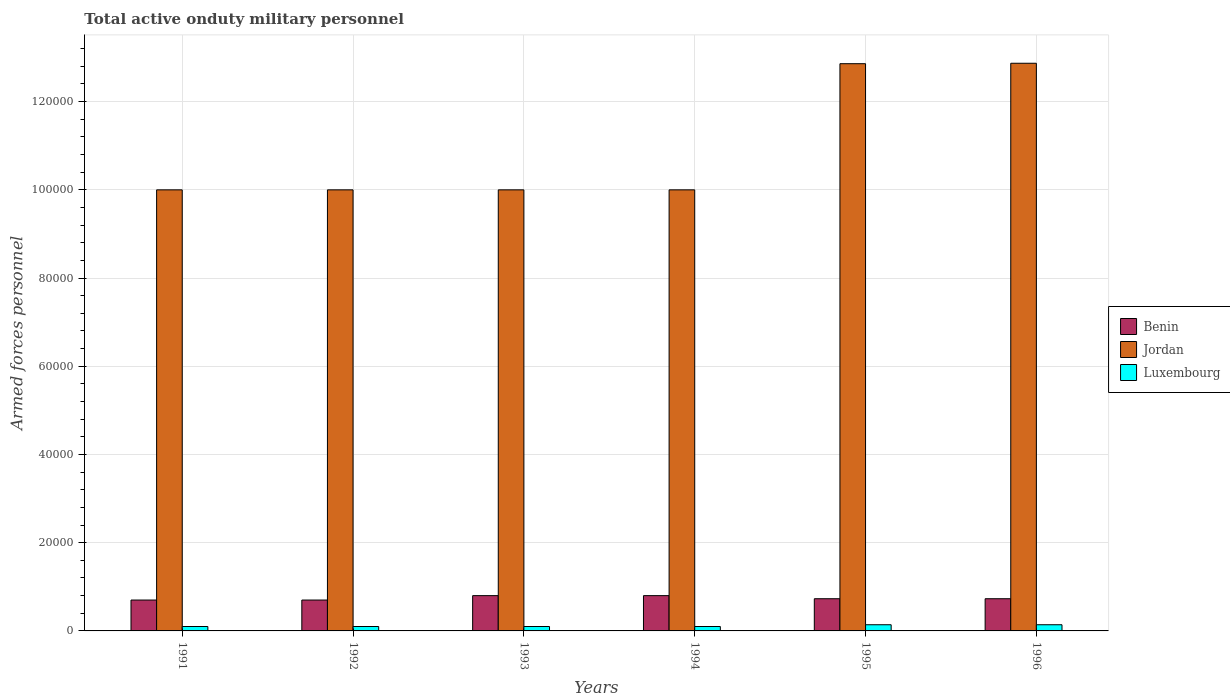How many different coloured bars are there?
Ensure brevity in your answer.  3. Are the number of bars on each tick of the X-axis equal?
Provide a short and direct response. Yes. How many bars are there on the 6th tick from the left?
Your response must be concise. 3. What is the label of the 2nd group of bars from the left?
Provide a succinct answer. 1992. What is the number of armed forces personnel in Jordan in 1995?
Your answer should be compact. 1.29e+05. Across all years, what is the maximum number of armed forces personnel in Luxembourg?
Your response must be concise. 1400. Across all years, what is the minimum number of armed forces personnel in Benin?
Your answer should be very brief. 7000. In which year was the number of armed forces personnel in Benin minimum?
Keep it short and to the point. 1991. What is the total number of armed forces personnel in Benin in the graph?
Make the answer very short. 4.46e+04. What is the difference between the number of armed forces personnel in Jordan in 1991 and that in 1995?
Provide a short and direct response. -2.86e+04. What is the difference between the number of armed forces personnel in Luxembourg in 1992 and the number of armed forces personnel in Jordan in 1995?
Offer a very short reply. -1.28e+05. What is the average number of armed forces personnel in Luxembourg per year?
Ensure brevity in your answer.  1133.33. In the year 1994, what is the difference between the number of armed forces personnel in Jordan and number of armed forces personnel in Luxembourg?
Your answer should be very brief. 9.90e+04. What is the ratio of the number of armed forces personnel in Jordan in 1993 to that in 1994?
Provide a succinct answer. 1. Is the number of armed forces personnel in Luxembourg in 1995 less than that in 1996?
Provide a short and direct response. No. What is the difference between the highest and the second highest number of armed forces personnel in Luxembourg?
Keep it short and to the point. 0. Is the sum of the number of armed forces personnel in Benin in 1992 and 1996 greater than the maximum number of armed forces personnel in Luxembourg across all years?
Provide a succinct answer. Yes. What does the 2nd bar from the left in 1995 represents?
Offer a very short reply. Jordan. What does the 2nd bar from the right in 1993 represents?
Offer a terse response. Jordan. How many bars are there?
Offer a terse response. 18. How many years are there in the graph?
Offer a terse response. 6. Are the values on the major ticks of Y-axis written in scientific E-notation?
Offer a very short reply. No. Where does the legend appear in the graph?
Ensure brevity in your answer.  Center right. How many legend labels are there?
Your answer should be very brief. 3. How are the legend labels stacked?
Make the answer very short. Vertical. What is the title of the graph?
Offer a very short reply. Total active onduty military personnel. What is the label or title of the Y-axis?
Give a very brief answer. Armed forces personnel. What is the Armed forces personnel of Benin in 1991?
Your response must be concise. 7000. What is the Armed forces personnel in Jordan in 1991?
Provide a succinct answer. 1.00e+05. What is the Armed forces personnel of Luxembourg in 1991?
Offer a terse response. 1000. What is the Armed forces personnel of Benin in 1992?
Offer a very short reply. 7000. What is the Armed forces personnel of Jordan in 1992?
Provide a succinct answer. 1.00e+05. What is the Armed forces personnel in Luxembourg in 1992?
Provide a short and direct response. 1000. What is the Armed forces personnel of Benin in 1993?
Keep it short and to the point. 8000. What is the Armed forces personnel of Jordan in 1993?
Ensure brevity in your answer.  1.00e+05. What is the Armed forces personnel in Benin in 1994?
Offer a terse response. 8000. What is the Armed forces personnel of Jordan in 1994?
Make the answer very short. 1.00e+05. What is the Armed forces personnel in Luxembourg in 1994?
Make the answer very short. 1000. What is the Armed forces personnel of Benin in 1995?
Offer a very short reply. 7300. What is the Armed forces personnel of Jordan in 1995?
Your response must be concise. 1.29e+05. What is the Armed forces personnel in Luxembourg in 1995?
Keep it short and to the point. 1400. What is the Armed forces personnel of Benin in 1996?
Make the answer very short. 7300. What is the Armed forces personnel of Jordan in 1996?
Offer a very short reply. 1.29e+05. What is the Armed forces personnel in Luxembourg in 1996?
Offer a terse response. 1400. Across all years, what is the maximum Armed forces personnel of Benin?
Give a very brief answer. 8000. Across all years, what is the maximum Armed forces personnel of Jordan?
Provide a short and direct response. 1.29e+05. Across all years, what is the maximum Armed forces personnel of Luxembourg?
Offer a terse response. 1400. Across all years, what is the minimum Armed forces personnel in Benin?
Give a very brief answer. 7000. Across all years, what is the minimum Armed forces personnel in Jordan?
Make the answer very short. 1.00e+05. Across all years, what is the minimum Armed forces personnel of Luxembourg?
Ensure brevity in your answer.  1000. What is the total Armed forces personnel in Benin in the graph?
Make the answer very short. 4.46e+04. What is the total Armed forces personnel of Jordan in the graph?
Give a very brief answer. 6.57e+05. What is the total Armed forces personnel in Luxembourg in the graph?
Your response must be concise. 6800. What is the difference between the Armed forces personnel in Benin in 1991 and that in 1992?
Your answer should be very brief. 0. What is the difference between the Armed forces personnel of Jordan in 1991 and that in 1992?
Ensure brevity in your answer.  0. What is the difference between the Armed forces personnel of Benin in 1991 and that in 1993?
Your answer should be compact. -1000. What is the difference between the Armed forces personnel in Jordan in 1991 and that in 1993?
Ensure brevity in your answer.  0. What is the difference between the Armed forces personnel of Luxembourg in 1991 and that in 1993?
Your answer should be compact. 0. What is the difference between the Armed forces personnel of Benin in 1991 and that in 1994?
Ensure brevity in your answer.  -1000. What is the difference between the Armed forces personnel of Benin in 1991 and that in 1995?
Keep it short and to the point. -300. What is the difference between the Armed forces personnel in Jordan in 1991 and that in 1995?
Your response must be concise. -2.86e+04. What is the difference between the Armed forces personnel in Luxembourg in 1991 and that in 1995?
Make the answer very short. -400. What is the difference between the Armed forces personnel of Benin in 1991 and that in 1996?
Provide a short and direct response. -300. What is the difference between the Armed forces personnel of Jordan in 1991 and that in 1996?
Give a very brief answer. -2.87e+04. What is the difference between the Armed forces personnel of Luxembourg in 1991 and that in 1996?
Keep it short and to the point. -400. What is the difference between the Armed forces personnel in Benin in 1992 and that in 1993?
Provide a succinct answer. -1000. What is the difference between the Armed forces personnel in Jordan in 1992 and that in 1993?
Provide a short and direct response. 0. What is the difference between the Armed forces personnel of Luxembourg in 1992 and that in 1993?
Offer a very short reply. 0. What is the difference between the Armed forces personnel of Benin in 1992 and that in 1994?
Your answer should be compact. -1000. What is the difference between the Armed forces personnel of Benin in 1992 and that in 1995?
Ensure brevity in your answer.  -300. What is the difference between the Armed forces personnel in Jordan in 1992 and that in 1995?
Ensure brevity in your answer.  -2.86e+04. What is the difference between the Armed forces personnel of Luxembourg in 1992 and that in 1995?
Make the answer very short. -400. What is the difference between the Armed forces personnel of Benin in 1992 and that in 1996?
Your answer should be compact. -300. What is the difference between the Armed forces personnel of Jordan in 1992 and that in 1996?
Your answer should be very brief. -2.87e+04. What is the difference between the Armed forces personnel of Luxembourg in 1992 and that in 1996?
Your answer should be compact. -400. What is the difference between the Armed forces personnel in Benin in 1993 and that in 1994?
Give a very brief answer. 0. What is the difference between the Armed forces personnel in Jordan in 1993 and that in 1994?
Your response must be concise. 0. What is the difference between the Armed forces personnel of Luxembourg in 1993 and that in 1994?
Make the answer very short. 0. What is the difference between the Armed forces personnel of Benin in 1993 and that in 1995?
Your answer should be very brief. 700. What is the difference between the Armed forces personnel in Jordan in 1993 and that in 1995?
Ensure brevity in your answer.  -2.86e+04. What is the difference between the Armed forces personnel in Luxembourg in 1993 and that in 1995?
Ensure brevity in your answer.  -400. What is the difference between the Armed forces personnel in Benin in 1993 and that in 1996?
Provide a succinct answer. 700. What is the difference between the Armed forces personnel of Jordan in 1993 and that in 1996?
Make the answer very short. -2.87e+04. What is the difference between the Armed forces personnel of Luxembourg in 1993 and that in 1996?
Make the answer very short. -400. What is the difference between the Armed forces personnel in Benin in 1994 and that in 1995?
Keep it short and to the point. 700. What is the difference between the Armed forces personnel in Jordan in 1994 and that in 1995?
Provide a succinct answer. -2.86e+04. What is the difference between the Armed forces personnel in Luxembourg in 1994 and that in 1995?
Your answer should be very brief. -400. What is the difference between the Armed forces personnel in Benin in 1994 and that in 1996?
Your answer should be very brief. 700. What is the difference between the Armed forces personnel in Jordan in 1994 and that in 1996?
Provide a short and direct response. -2.87e+04. What is the difference between the Armed forces personnel in Luxembourg in 1994 and that in 1996?
Your answer should be compact. -400. What is the difference between the Armed forces personnel of Jordan in 1995 and that in 1996?
Your answer should be compact. -100. What is the difference between the Armed forces personnel of Luxembourg in 1995 and that in 1996?
Your response must be concise. 0. What is the difference between the Armed forces personnel in Benin in 1991 and the Armed forces personnel in Jordan in 1992?
Your answer should be very brief. -9.30e+04. What is the difference between the Armed forces personnel of Benin in 1991 and the Armed forces personnel of Luxembourg in 1992?
Your response must be concise. 6000. What is the difference between the Armed forces personnel in Jordan in 1991 and the Armed forces personnel in Luxembourg in 1992?
Your answer should be very brief. 9.90e+04. What is the difference between the Armed forces personnel of Benin in 1991 and the Armed forces personnel of Jordan in 1993?
Keep it short and to the point. -9.30e+04. What is the difference between the Armed forces personnel in Benin in 1991 and the Armed forces personnel in Luxembourg in 1993?
Your response must be concise. 6000. What is the difference between the Armed forces personnel in Jordan in 1991 and the Armed forces personnel in Luxembourg in 1993?
Provide a succinct answer. 9.90e+04. What is the difference between the Armed forces personnel of Benin in 1991 and the Armed forces personnel of Jordan in 1994?
Give a very brief answer. -9.30e+04. What is the difference between the Armed forces personnel of Benin in 1991 and the Armed forces personnel of Luxembourg in 1994?
Your answer should be very brief. 6000. What is the difference between the Armed forces personnel of Jordan in 1991 and the Armed forces personnel of Luxembourg in 1994?
Make the answer very short. 9.90e+04. What is the difference between the Armed forces personnel of Benin in 1991 and the Armed forces personnel of Jordan in 1995?
Keep it short and to the point. -1.22e+05. What is the difference between the Armed forces personnel of Benin in 1991 and the Armed forces personnel of Luxembourg in 1995?
Provide a short and direct response. 5600. What is the difference between the Armed forces personnel in Jordan in 1991 and the Armed forces personnel in Luxembourg in 1995?
Provide a short and direct response. 9.86e+04. What is the difference between the Armed forces personnel of Benin in 1991 and the Armed forces personnel of Jordan in 1996?
Provide a short and direct response. -1.22e+05. What is the difference between the Armed forces personnel in Benin in 1991 and the Armed forces personnel in Luxembourg in 1996?
Keep it short and to the point. 5600. What is the difference between the Armed forces personnel of Jordan in 1991 and the Armed forces personnel of Luxembourg in 1996?
Ensure brevity in your answer.  9.86e+04. What is the difference between the Armed forces personnel in Benin in 1992 and the Armed forces personnel in Jordan in 1993?
Keep it short and to the point. -9.30e+04. What is the difference between the Armed forces personnel in Benin in 1992 and the Armed forces personnel in Luxembourg in 1993?
Keep it short and to the point. 6000. What is the difference between the Armed forces personnel of Jordan in 1992 and the Armed forces personnel of Luxembourg in 1993?
Ensure brevity in your answer.  9.90e+04. What is the difference between the Armed forces personnel in Benin in 1992 and the Armed forces personnel in Jordan in 1994?
Ensure brevity in your answer.  -9.30e+04. What is the difference between the Armed forces personnel in Benin in 1992 and the Armed forces personnel in Luxembourg in 1994?
Your answer should be compact. 6000. What is the difference between the Armed forces personnel of Jordan in 1992 and the Armed forces personnel of Luxembourg in 1994?
Your response must be concise. 9.90e+04. What is the difference between the Armed forces personnel in Benin in 1992 and the Armed forces personnel in Jordan in 1995?
Make the answer very short. -1.22e+05. What is the difference between the Armed forces personnel in Benin in 1992 and the Armed forces personnel in Luxembourg in 1995?
Your answer should be compact. 5600. What is the difference between the Armed forces personnel in Jordan in 1992 and the Armed forces personnel in Luxembourg in 1995?
Provide a short and direct response. 9.86e+04. What is the difference between the Armed forces personnel of Benin in 1992 and the Armed forces personnel of Jordan in 1996?
Offer a terse response. -1.22e+05. What is the difference between the Armed forces personnel of Benin in 1992 and the Armed forces personnel of Luxembourg in 1996?
Your answer should be very brief. 5600. What is the difference between the Armed forces personnel in Jordan in 1992 and the Armed forces personnel in Luxembourg in 1996?
Give a very brief answer. 9.86e+04. What is the difference between the Armed forces personnel of Benin in 1993 and the Armed forces personnel of Jordan in 1994?
Make the answer very short. -9.20e+04. What is the difference between the Armed forces personnel in Benin in 1993 and the Armed forces personnel in Luxembourg in 1994?
Provide a short and direct response. 7000. What is the difference between the Armed forces personnel of Jordan in 1993 and the Armed forces personnel of Luxembourg in 1994?
Ensure brevity in your answer.  9.90e+04. What is the difference between the Armed forces personnel of Benin in 1993 and the Armed forces personnel of Jordan in 1995?
Make the answer very short. -1.21e+05. What is the difference between the Armed forces personnel in Benin in 1993 and the Armed forces personnel in Luxembourg in 1995?
Your response must be concise. 6600. What is the difference between the Armed forces personnel of Jordan in 1993 and the Armed forces personnel of Luxembourg in 1995?
Ensure brevity in your answer.  9.86e+04. What is the difference between the Armed forces personnel of Benin in 1993 and the Armed forces personnel of Jordan in 1996?
Provide a succinct answer. -1.21e+05. What is the difference between the Armed forces personnel in Benin in 1993 and the Armed forces personnel in Luxembourg in 1996?
Keep it short and to the point. 6600. What is the difference between the Armed forces personnel of Jordan in 1993 and the Armed forces personnel of Luxembourg in 1996?
Offer a terse response. 9.86e+04. What is the difference between the Armed forces personnel in Benin in 1994 and the Armed forces personnel in Jordan in 1995?
Your response must be concise. -1.21e+05. What is the difference between the Armed forces personnel of Benin in 1994 and the Armed forces personnel of Luxembourg in 1995?
Make the answer very short. 6600. What is the difference between the Armed forces personnel of Jordan in 1994 and the Armed forces personnel of Luxembourg in 1995?
Your response must be concise. 9.86e+04. What is the difference between the Armed forces personnel in Benin in 1994 and the Armed forces personnel in Jordan in 1996?
Your answer should be very brief. -1.21e+05. What is the difference between the Armed forces personnel of Benin in 1994 and the Armed forces personnel of Luxembourg in 1996?
Your response must be concise. 6600. What is the difference between the Armed forces personnel in Jordan in 1994 and the Armed forces personnel in Luxembourg in 1996?
Provide a succinct answer. 9.86e+04. What is the difference between the Armed forces personnel in Benin in 1995 and the Armed forces personnel in Jordan in 1996?
Your answer should be compact. -1.21e+05. What is the difference between the Armed forces personnel of Benin in 1995 and the Armed forces personnel of Luxembourg in 1996?
Offer a very short reply. 5900. What is the difference between the Armed forces personnel in Jordan in 1995 and the Armed forces personnel in Luxembourg in 1996?
Your answer should be very brief. 1.27e+05. What is the average Armed forces personnel of Benin per year?
Ensure brevity in your answer.  7433.33. What is the average Armed forces personnel in Jordan per year?
Keep it short and to the point. 1.10e+05. What is the average Armed forces personnel in Luxembourg per year?
Give a very brief answer. 1133.33. In the year 1991, what is the difference between the Armed forces personnel of Benin and Armed forces personnel of Jordan?
Provide a short and direct response. -9.30e+04. In the year 1991, what is the difference between the Armed forces personnel in Benin and Armed forces personnel in Luxembourg?
Ensure brevity in your answer.  6000. In the year 1991, what is the difference between the Armed forces personnel of Jordan and Armed forces personnel of Luxembourg?
Your answer should be compact. 9.90e+04. In the year 1992, what is the difference between the Armed forces personnel in Benin and Armed forces personnel in Jordan?
Offer a very short reply. -9.30e+04. In the year 1992, what is the difference between the Armed forces personnel in Benin and Armed forces personnel in Luxembourg?
Ensure brevity in your answer.  6000. In the year 1992, what is the difference between the Armed forces personnel in Jordan and Armed forces personnel in Luxembourg?
Your answer should be compact. 9.90e+04. In the year 1993, what is the difference between the Armed forces personnel in Benin and Armed forces personnel in Jordan?
Give a very brief answer. -9.20e+04. In the year 1993, what is the difference between the Armed forces personnel of Benin and Armed forces personnel of Luxembourg?
Ensure brevity in your answer.  7000. In the year 1993, what is the difference between the Armed forces personnel in Jordan and Armed forces personnel in Luxembourg?
Your answer should be compact. 9.90e+04. In the year 1994, what is the difference between the Armed forces personnel in Benin and Armed forces personnel in Jordan?
Give a very brief answer. -9.20e+04. In the year 1994, what is the difference between the Armed forces personnel of Benin and Armed forces personnel of Luxembourg?
Give a very brief answer. 7000. In the year 1994, what is the difference between the Armed forces personnel of Jordan and Armed forces personnel of Luxembourg?
Give a very brief answer. 9.90e+04. In the year 1995, what is the difference between the Armed forces personnel of Benin and Armed forces personnel of Jordan?
Your answer should be very brief. -1.21e+05. In the year 1995, what is the difference between the Armed forces personnel of Benin and Armed forces personnel of Luxembourg?
Your answer should be compact. 5900. In the year 1995, what is the difference between the Armed forces personnel in Jordan and Armed forces personnel in Luxembourg?
Make the answer very short. 1.27e+05. In the year 1996, what is the difference between the Armed forces personnel of Benin and Armed forces personnel of Jordan?
Your answer should be very brief. -1.21e+05. In the year 1996, what is the difference between the Armed forces personnel in Benin and Armed forces personnel in Luxembourg?
Give a very brief answer. 5900. In the year 1996, what is the difference between the Armed forces personnel in Jordan and Armed forces personnel in Luxembourg?
Offer a terse response. 1.27e+05. What is the ratio of the Armed forces personnel in Benin in 1991 to that in 1993?
Your answer should be very brief. 0.88. What is the ratio of the Armed forces personnel of Luxembourg in 1991 to that in 1993?
Offer a terse response. 1. What is the ratio of the Armed forces personnel of Benin in 1991 to that in 1995?
Your answer should be very brief. 0.96. What is the ratio of the Armed forces personnel in Jordan in 1991 to that in 1995?
Provide a succinct answer. 0.78. What is the ratio of the Armed forces personnel of Benin in 1991 to that in 1996?
Your answer should be compact. 0.96. What is the ratio of the Armed forces personnel in Jordan in 1991 to that in 1996?
Keep it short and to the point. 0.78. What is the ratio of the Armed forces personnel in Luxembourg in 1991 to that in 1996?
Offer a terse response. 0.71. What is the ratio of the Armed forces personnel of Benin in 1992 to that in 1993?
Your answer should be compact. 0.88. What is the ratio of the Armed forces personnel of Jordan in 1992 to that in 1993?
Your answer should be compact. 1. What is the ratio of the Armed forces personnel in Benin in 1992 to that in 1994?
Offer a terse response. 0.88. What is the ratio of the Armed forces personnel of Jordan in 1992 to that in 1994?
Your response must be concise. 1. What is the ratio of the Armed forces personnel in Luxembourg in 1992 to that in 1994?
Offer a very short reply. 1. What is the ratio of the Armed forces personnel of Benin in 1992 to that in 1995?
Offer a terse response. 0.96. What is the ratio of the Armed forces personnel of Jordan in 1992 to that in 1995?
Your answer should be compact. 0.78. What is the ratio of the Armed forces personnel in Luxembourg in 1992 to that in 1995?
Offer a terse response. 0.71. What is the ratio of the Armed forces personnel of Benin in 1992 to that in 1996?
Offer a terse response. 0.96. What is the ratio of the Armed forces personnel in Jordan in 1992 to that in 1996?
Provide a short and direct response. 0.78. What is the ratio of the Armed forces personnel of Benin in 1993 to that in 1994?
Make the answer very short. 1. What is the ratio of the Armed forces personnel in Jordan in 1993 to that in 1994?
Give a very brief answer. 1. What is the ratio of the Armed forces personnel in Luxembourg in 1993 to that in 1994?
Your answer should be compact. 1. What is the ratio of the Armed forces personnel of Benin in 1993 to that in 1995?
Give a very brief answer. 1.1. What is the ratio of the Armed forces personnel in Jordan in 1993 to that in 1995?
Your response must be concise. 0.78. What is the ratio of the Armed forces personnel in Luxembourg in 1993 to that in 1995?
Keep it short and to the point. 0.71. What is the ratio of the Armed forces personnel of Benin in 1993 to that in 1996?
Your answer should be compact. 1.1. What is the ratio of the Armed forces personnel in Jordan in 1993 to that in 1996?
Give a very brief answer. 0.78. What is the ratio of the Armed forces personnel of Benin in 1994 to that in 1995?
Provide a succinct answer. 1.1. What is the ratio of the Armed forces personnel in Jordan in 1994 to that in 1995?
Offer a very short reply. 0.78. What is the ratio of the Armed forces personnel of Benin in 1994 to that in 1996?
Give a very brief answer. 1.1. What is the ratio of the Armed forces personnel of Jordan in 1994 to that in 1996?
Keep it short and to the point. 0.78. What is the ratio of the Armed forces personnel of Jordan in 1995 to that in 1996?
Offer a very short reply. 1. What is the difference between the highest and the second highest Armed forces personnel in Benin?
Your response must be concise. 0. What is the difference between the highest and the second highest Armed forces personnel of Jordan?
Your answer should be very brief. 100. What is the difference between the highest and the lowest Armed forces personnel in Benin?
Your answer should be compact. 1000. What is the difference between the highest and the lowest Armed forces personnel of Jordan?
Your answer should be compact. 2.87e+04. What is the difference between the highest and the lowest Armed forces personnel in Luxembourg?
Make the answer very short. 400. 